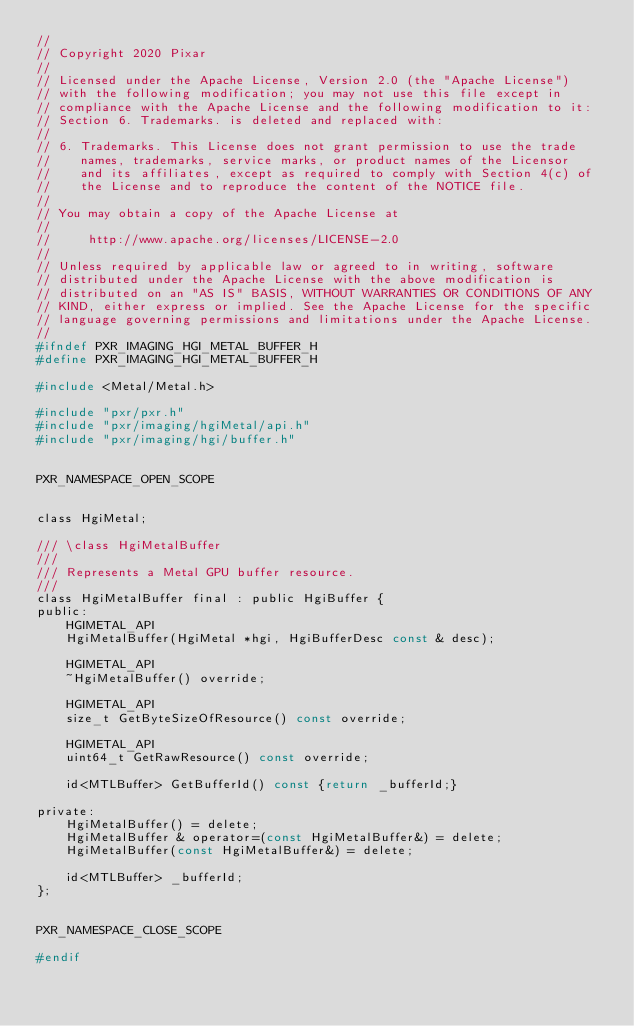<code> <loc_0><loc_0><loc_500><loc_500><_C_>//
// Copyright 2020 Pixar
//
// Licensed under the Apache License, Version 2.0 (the "Apache License")
// with the following modification; you may not use this file except in
// compliance with the Apache License and the following modification to it:
// Section 6. Trademarks. is deleted and replaced with:
//
// 6. Trademarks. This License does not grant permission to use the trade
//    names, trademarks, service marks, or product names of the Licensor
//    and its affiliates, except as required to comply with Section 4(c) of
//    the License and to reproduce the content of the NOTICE file.
//
// You may obtain a copy of the Apache License at
//
//     http://www.apache.org/licenses/LICENSE-2.0
//
// Unless required by applicable law or agreed to in writing, software
// distributed under the Apache License with the above modification is
// distributed on an "AS IS" BASIS, WITHOUT WARRANTIES OR CONDITIONS OF ANY
// KIND, either express or implied. See the Apache License for the specific
// language governing permissions and limitations under the Apache License.
//
#ifndef PXR_IMAGING_HGI_METAL_BUFFER_H
#define PXR_IMAGING_HGI_METAL_BUFFER_H

#include <Metal/Metal.h>

#include "pxr/pxr.h"
#include "pxr/imaging/hgiMetal/api.h"
#include "pxr/imaging/hgi/buffer.h"


PXR_NAMESPACE_OPEN_SCOPE


class HgiMetal;

/// \class HgiMetalBuffer
///
/// Represents a Metal GPU buffer resource.
///
class HgiMetalBuffer final : public HgiBuffer {
public:
    HGIMETAL_API
    HgiMetalBuffer(HgiMetal *hgi, HgiBufferDesc const & desc);

    HGIMETAL_API
    ~HgiMetalBuffer() override;

    HGIMETAL_API
    size_t GetByteSizeOfResource() const override;

    HGIMETAL_API
    uint64_t GetRawResource() const override;

    id<MTLBuffer> GetBufferId() const {return _bufferId;}

private:
    HgiMetalBuffer() = delete;
    HgiMetalBuffer & operator=(const HgiMetalBuffer&) = delete;
    HgiMetalBuffer(const HgiMetalBuffer&) = delete;

    id<MTLBuffer> _bufferId;
};


PXR_NAMESPACE_CLOSE_SCOPE

#endif
</code> 